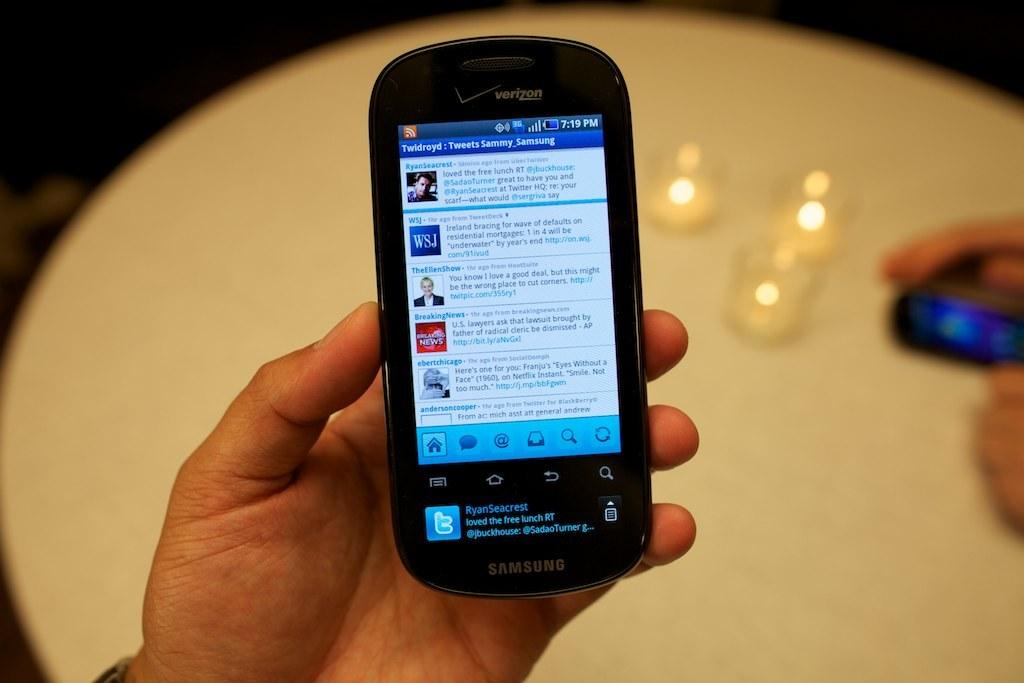What is the person holding in the image? There is a hand holding a cellphone in the image. What else can be seen in the image besides the hand and cellphone? There are glasses in the image. Where is the mobile phone located in the image? The mobile phone is placed on a table in the image. What type of beef is being cooked in the image? There is no beef present in the image; it features a hand holding a cellphone, glasses, and a mobile phone on a table. What color is the mist surrounding the objects in the image? There is no mist present in the image; it is a clear image featuring a hand holding a cellphone, glasses, and a mobile phone on a table. 